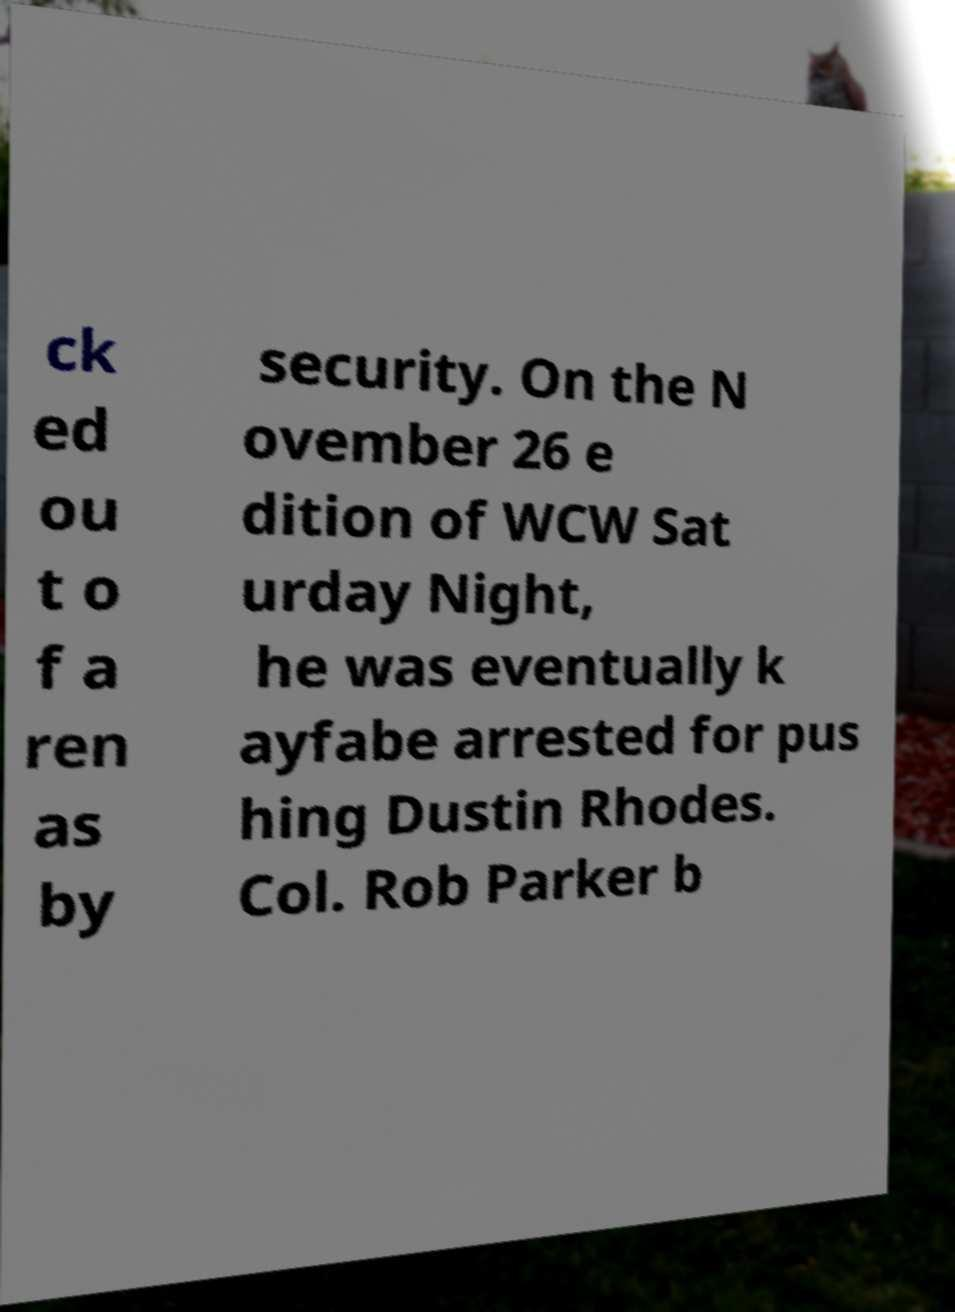For documentation purposes, I need the text within this image transcribed. Could you provide that? ck ed ou t o f a ren as by security. On the N ovember 26 e dition of WCW Sat urday Night, he was eventually k ayfabe arrested for pus hing Dustin Rhodes. Col. Rob Parker b 